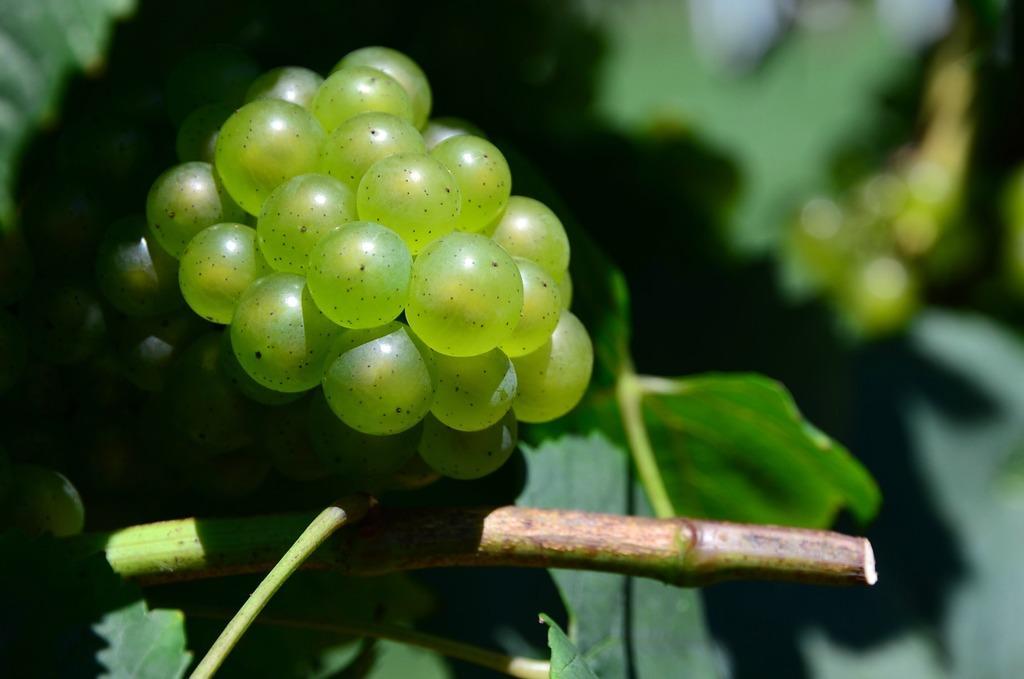Can you describe this image briefly? In this image I can see the green color fruits to the plant. I can see the blurred background. 